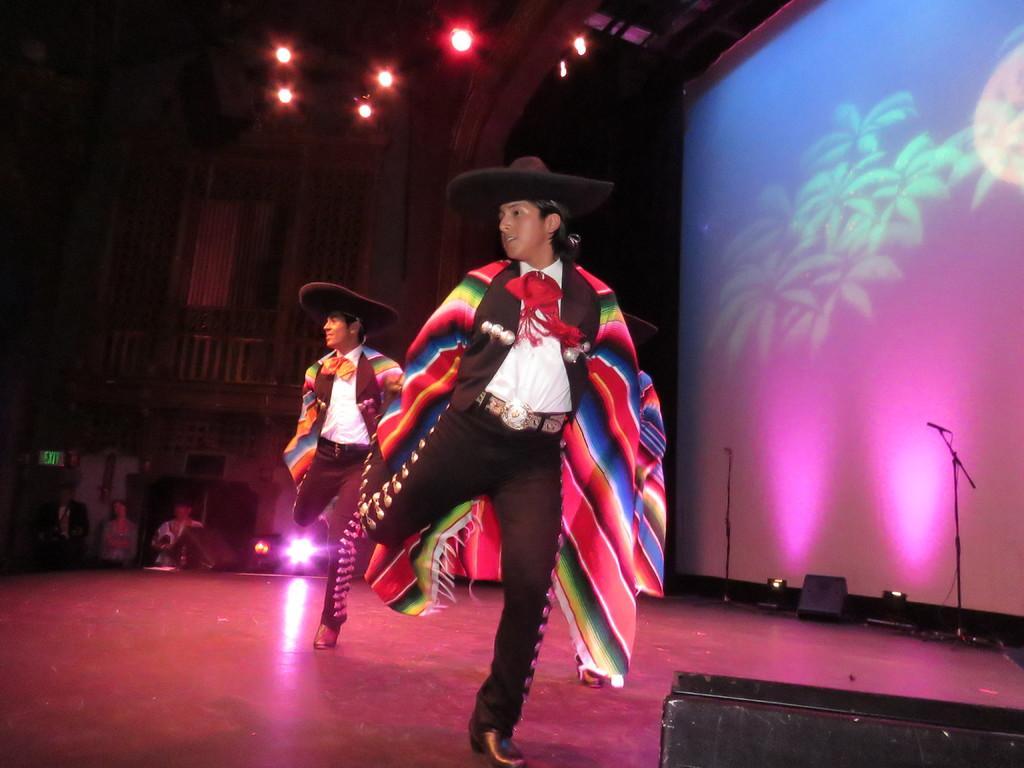How would you summarize this image in a sentence or two? In the middle of this image, there are two persons wearing caps and dancing on a stage, on which, there are lights, stands, a speaker and other objects. In the background, there are lights attached to the roof and there is a screen. 